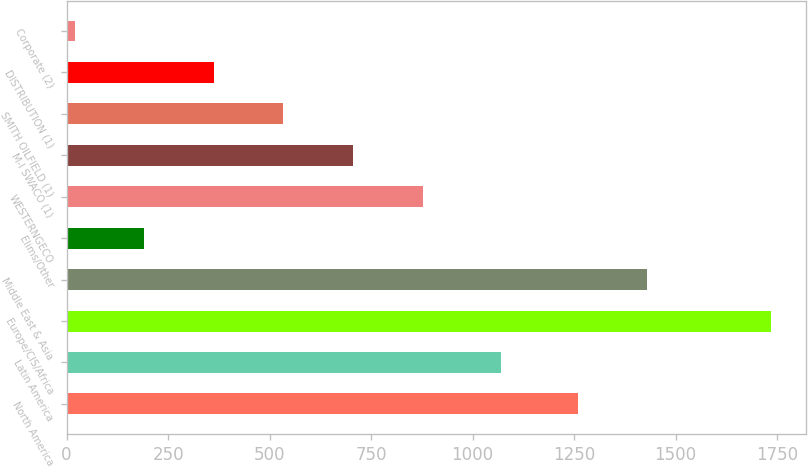Convert chart to OTSL. <chart><loc_0><loc_0><loc_500><loc_500><bar_chart><fcel>North America<fcel>Latin America<fcel>Europe/CIS/Africa<fcel>Middle East & Asia<fcel>Elims/Other<fcel>WESTERNGECO<fcel>M-I SWACO (1)<fcel>SMITH OILFIELD (1)<fcel>DISTRIBUTION (1)<fcel>Corporate (2)<nl><fcel>1259<fcel>1071<fcel>1734<fcel>1430.4<fcel>191.4<fcel>877<fcel>705.6<fcel>534.2<fcel>362.8<fcel>20<nl></chart> 